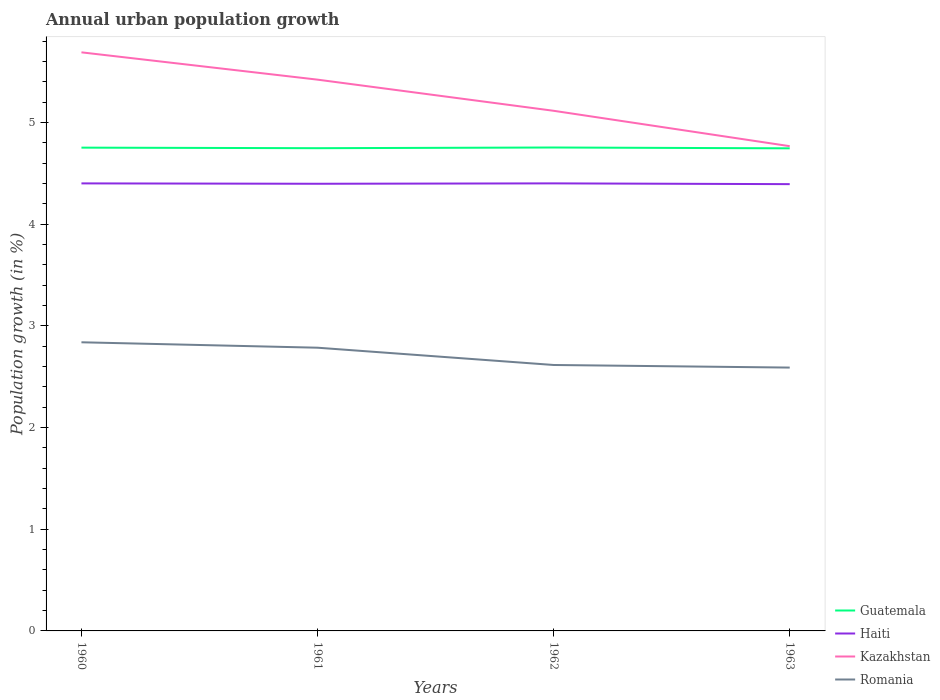How many different coloured lines are there?
Keep it short and to the point. 4. Is the number of lines equal to the number of legend labels?
Ensure brevity in your answer.  Yes. Across all years, what is the maximum percentage of urban population growth in Haiti?
Your answer should be compact. 4.39. What is the total percentage of urban population growth in Haiti in the graph?
Offer a terse response. -7.547159745957543e-5. What is the difference between the highest and the second highest percentage of urban population growth in Kazakhstan?
Offer a terse response. 0.92. Is the percentage of urban population growth in Romania strictly greater than the percentage of urban population growth in Haiti over the years?
Offer a terse response. Yes. How many lines are there?
Your answer should be compact. 4. How many years are there in the graph?
Offer a terse response. 4. What is the title of the graph?
Give a very brief answer. Annual urban population growth. Does "Argentina" appear as one of the legend labels in the graph?
Provide a short and direct response. No. What is the label or title of the X-axis?
Your answer should be very brief. Years. What is the label or title of the Y-axis?
Keep it short and to the point. Population growth (in %). What is the Population growth (in %) in Guatemala in 1960?
Offer a terse response. 4.75. What is the Population growth (in %) of Haiti in 1960?
Offer a very short reply. 4.4. What is the Population growth (in %) in Kazakhstan in 1960?
Keep it short and to the point. 5.69. What is the Population growth (in %) in Romania in 1960?
Offer a very short reply. 2.84. What is the Population growth (in %) of Guatemala in 1961?
Ensure brevity in your answer.  4.75. What is the Population growth (in %) of Haiti in 1961?
Ensure brevity in your answer.  4.4. What is the Population growth (in %) of Kazakhstan in 1961?
Provide a succinct answer. 5.42. What is the Population growth (in %) in Romania in 1961?
Your answer should be compact. 2.79. What is the Population growth (in %) in Guatemala in 1962?
Give a very brief answer. 4.75. What is the Population growth (in %) in Haiti in 1962?
Provide a succinct answer. 4.4. What is the Population growth (in %) in Kazakhstan in 1962?
Make the answer very short. 5.12. What is the Population growth (in %) of Romania in 1962?
Give a very brief answer. 2.62. What is the Population growth (in %) in Guatemala in 1963?
Give a very brief answer. 4.75. What is the Population growth (in %) of Haiti in 1963?
Make the answer very short. 4.39. What is the Population growth (in %) in Kazakhstan in 1963?
Offer a very short reply. 4.77. What is the Population growth (in %) of Romania in 1963?
Your response must be concise. 2.59. Across all years, what is the maximum Population growth (in %) of Guatemala?
Make the answer very short. 4.75. Across all years, what is the maximum Population growth (in %) in Haiti?
Give a very brief answer. 4.4. Across all years, what is the maximum Population growth (in %) of Kazakhstan?
Give a very brief answer. 5.69. Across all years, what is the maximum Population growth (in %) of Romania?
Offer a very short reply. 2.84. Across all years, what is the minimum Population growth (in %) of Guatemala?
Give a very brief answer. 4.75. Across all years, what is the minimum Population growth (in %) of Haiti?
Keep it short and to the point. 4.39. Across all years, what is the minimum Population growth (in %) of Kazakhstan?
Offer a very short reply. 4.77. Across all years, what is the minimum Population growth (in %) of Romania?
Provide a short and direct response. 2.59. What is the total Population growth (in %) of Guatemala in the graph?
Your answer should be very brief. 19. What is the total Population growth (in %) in Haiti in the graph?
Offer a very short reply. 17.59. What is the total Population growth (in %) of Kazakhstan in the graph?
Your answer should be very brief. 20.99. What is the total Population growth (in %) of Romania in the graph?
Give a very brief answer. 10.83. What is the difference between the Population growth (in %) in Guatemala in 1960 and that in 1961?
Offer a terse response. 0.01. What is the difference between the Population growth (in %) in Haiti in 1960 and that in 1961?
Offer a terse response. 0. What is the difference between the Population growth (in %) of Kazakhstan in 1960 and that in 1961?
Offer a very short reply. 0.27. What is the difference between the Population growth (in %) in Romania in 1960 and that in 1961?
Make the answer very short. 0.05. What is the difference between the Population growth (in %) of Guatemala in 1960 and that in 1962?
Offer a very short reply. -0. What is the difference between the Population growth (in %) in Haiti in 1960 and that in 1962?
Your answer should be compact. -0. What is the difference between the Population growth (in %) in Kazakhstan in 1960 and that in 1962?
Offer a terse response. 0.57. What is the difference between the Population growth (in %) in Romania in 1960 and that in 1962?
Keep it short and to the point. 0.22. What is the difference between the Population growth (in %) in Guatemala in 1960 and that in 1963?
Offer a very short reply. 0.01. What is the difference between the Population growth (in %) of Haiti in 1960 and that in 1963?
Your answer should be very brief. 0.01. What is the difference between the Population growth (in %) of Kazakhstan in 1960 and that in 1963?
Keep it short and to the point. 0.92. What is the difference between the Population growth (in %) of Romania in 1960 and that in 1963?
Keep it short and to the point. 0.25. What is the difference between the Population growth (in %) of Guatemala in 1961 and that in 1962?
Keep it short and to the point. -0.01. What is the difference between the Population growth (in %) in Haiti in 1961 and that in 1962?
Provide a succinct answer. -0. What is the difference between the Population growth (in %) in Kazakhstan in 1961 and that in 1962?
Offer a very short reply. 0.31. What is the difference between the Population growth (in %) in Romania in 1961 and that in 1962?
Provide a succinct answer. 0.17. What is the difference between the Population growth (in %) in Guatemala in 1961 and that in 1963?
Make the answer very short. 0. What is the difference between the Population growth (in %) in Haiti in 1961 and that in 1963?
Your answer should be compact. 0. What is the difference between the Population growth (in %) in Kazakhstan in 1961 and that in 1963?
Offer a very short reply. 0.65. What is the difference between the Population growth (in %) of Romania in 1961 and that in 1963?
Your response must be concise. 0.2. What is the difference between the Population growth (in %) in Guatemala in 1962 and that in 1963?
Provide a short and direct response. 0.01. What is the difference between the Population growth (in %) in Haiti in 1962 and that in 1963?
Your answer should be very brief. 0.01. What is the difference between the Population growth (in %) of Kazakhstan in 1962 and that in 1963?
Provide a succinct answer. 0.35. What is the difference between the Population growth (in %) of Romania in 1962 and that in 1963?
Give a very brief answer. 0.03. What is the difference between the Population growth (in %) in Guatemala in 1960 and the Population growth (in %) in Haiti in 1961?
Give a very brief answer. 0.36. What is the difference between the Population growth (in %) of Guatemala in 1960 and the Population growth (in %) of Kazakhstan in 1961?
Keep it short and to the point. -0.67. What is the difference between the Population growth (in %) in Guatemala in 1960 and the Population growth (in %) in Romania in 1961?
Keep it short and to the point. 1.97. What is the difference between the Population growth (in %) of Haiti in 1960 and the Population growth (in %) of Kazakhstan in 1961?
Make the answer very short. -1.02. What is the difference between the Population growth (in %) in Haiti in 1960 and the Population growth (in %) in Romania in 1961?
Your answer should be compact. 1.62. What is the difference between the Population growth (in %) in Kazakhstan in 1960 and the Population growth (in %) in Romania in 1961?
Make the answer very short. 2.9. What is the difference between the Population growth (in %) in Guatemala in 1960 and the Population growth (in %) in Haiti in 1962?
Ensure brevity in your answer.  0.35. What is the difference between the Population growth (in %) in Guatemala in 1960 and the Population growth (in %) in Kazakhstan in 1962?
Make the answer very short. -0.36. What is the difference between the Population growth (in %) in Guatemala in 1960 and the Population growth (in %) in Romania in 1962?
Provide a short and direct response. 2.14. What is the difference between the Population growth (in %) in Haiti in 1960 and the Population growth (in %) in Kazakhstan in 1962?
Provide a succinct answer. -0.71. What is the difference between the Population growth (in %) of Haiti in 1960 and the Population growth (in %) of Romania in 1962?
Make the answer very short. 1.79. What is the difference between the Population growth (in %) of Kazakhstan in 1960 and the Population growth (in %) of Romania in 1962?
Your response must be concise. 3.07. What is the difference between the Population growth (in %) of Guatemala in 1960 and the Population growth (in %) of Haiti in 1963?
Make the answer very short. 0.36. What is the difference between the Population growth (in %) in Guatemala in 1960 and the Population growth (in %) in Kazakhstan in 1963?
Provide a succinct answer. -0.01. What is the difference between the Population growth (in %) of Guatemala in 1960 and the Population growth (in %) of Romania in 1963?
Give a very brief answer. 2.16. What is the difference between the Population growth (in %) in Haiti in 1960 and the Population growth (in %) in Kazakhstan in 1963?
Provide a short and direct response. -0.37. What is the difference between the Population growth (in %) of Haiti in 1960 and the Population growth (in %) of Romania in 1963?
Offer a very short reply. 1.81. What is the difference between the Population growth (in %) of Kazakhstan in 1960 and the Population growth (in %) of Romania in 1963?
Provide a succinct answer. 3.1. What is the difference between the Population growth (in %) in Guatemala in 1961 and the Population growth (in %) in Haiti in 1962?
Your answer should be compact. 0.35. What is the difference between the Population growth (in %) in Guatemala in 1961 and the Population growth (in %) in Kazakhstan in 1962?
Keep it short and to the point. -0.37. What is the difference between the Population growth (in %) of Guatemala in 1961 and the Population growth (in %) of Romania in 1962?
Offer a terse response. 2.13. What is the difference between the Population growth (in %) of Haiti in 1961 and the Population growth (in %) of Kazakhstan in 1962?
Your answer should be very brief. -0.72. What is the difference between the Population growth (in %) in Haiti in 1961 and the Population growth (in %) in Romania in 1962?
Keep it short and to the point. 1.78. What is the difference between the Population growth (in %) in Kazakhstan in 1961 and the Population growth (in %) in Romania in 1962?
Ensure brevity in your answer.  2.81. What is the difference between the Population growth (in %) in Guatemala in 1961 and the Population growth (in %) in Haiti in 1963?
Your response must be concise. 0.35. What is the difference between the Population growth (in %) in Guatemala in 1961 and the Population growth (in %) in Kazakhstan in 1963?
Give a very brief answer. -0.02. What is the difference between the Population growth (in %) of Guatemala in 1961 and the Population growth (in %) of Romania in 1963?
Your answer should be very brief. 2.16. What is the difference between the Population growth (in %) in Haiti in 1961 and the Population growth (in %) in Kazakhstan in 1963?
Keep it short and to the point. -0.37. What is the difference between the Population growth (in %) in Haiti in 1961 and the Population growth (in %) in Romania in 1963?
Give a very brief answer. 1.81. What is the difference between the Population growth (in %) of Kazakhstan in 1961 and the Population growth (in %) of Romania in 1963?
Keep it short and to the point. 2.83. What is the difference between the Population growth (in %) in Guatemala in 1962 and the Population growth (in %) in Haiti in 1963?
Ensure brevity in your answer.  0.36. What is the difference between the Population growth (in %) of Guatemala in 1962 and the Population growth (in %) of Kazakhstan in 1963?
Make the answer very short. -0.01. What is the difference between the Population growth (in %) in Guatemala in 1962 and the Population growth (in %) in Romania in 1963?
Your answer should be very brief. 2.16. What is the difference between the Population growth (in %) in Haiti in 1962 and the Population growth (in %) in Kazakhstan in 1963?
Give a very brief answer. -0.37. What is the difference between the Population growth (in %) in Haiti in 1962 and the Population growth (in %) in Romania in 1963?
Offer a very short reply. 1.81. What is the difference between the Population growth (in %) of Kazakhstan in 1962 and the Population growth (in %) of Romania in 1963?
Provide a succinct answer. 2.53. What is the average Population growth (in %) of Guatemala per year?
Give a very brief answer. 4.75. What is the average Population growth (in %) of Haiti per year?
Your response must be concise. 4.4. What is the average Population growth (in %) of Kazakhstan per year?
Provide a short and direct response. 5.25. What is the average Population growth (in %) in Romania per year?
Ensure brevity in your answer.  2.71. In the year 1960, what is the difference between the Population growth (in %) of Guatemala and Population growth (in %) of Haiti?
Your answer should be compact. 0.35. In the year 1960, what is the difference between the Population growth (in %) in Guatemala and Population growth (in %) in Kazakhstan?
Provide a short and direct response. -0.94. In the year 1960, what is the difference between the Population growth (in %) in Guatemala and Population growth (in %) in Romania?
Your answer should be compact. 1.91. In the year 1960, what is the difference between the Population growth (in %) in Haiti and Population growth (in %) in Kazakhstan?
Provide a short and direct response. -1.29. In the year 1960, what is the difference between the Population growth (in %) in Haiti and Population growth (in %) in Romania?
Provide a succinct answer. 1.56. In the year 1960, what is the difference between the Population growth (in %) in Kazakhstan and Population growth (in %) in Romania?
Keep it short and to the point. 2.85. In the year 1961, what is the difference between the Population growth (in %) of Guatemala and Population growth (in %) of Kazakhstan?
Make the answer very short. -0.67. In the year 1961, what is the difference between the Population growth (in %) in Guatemala and Population growth (in %) in Romania?
Your answer should be compact. 1.96. In the year 1961, what is the difference between the Population growth (in %) in Haiti and Population growth (in %) in Kazakhstan?
Offer a very short reply. -1.02. In the year 1961, what is the difference between the Population growth (in %) in Haiti and Population growth (in %) in Romania?
Your answer should be very brief. 1.61. In the year 1961, what is the difference between the Population growth (in %) of Kazakhstan and Population growth (in %) of Romania?
Make the answer very short. 2.64. In the year 1962, what is the difference between the Population growth (in %) in Guatemala and Population growth (in %) in Haiti?
Give a very brief answer. 0.35. In the year 1962, what is the difference between the Population growth (in %) in Guatemala and Population growth (in %) in Kazakhstan?
Keep it short and to the point. -0.36. In the year 1962, what is the difference between the Population growth (in %) in Guatemala and Population growth (in %) in Romania?
Provide a short and direct response. 2.14. In the year 1962, what is the difference between the Population growth (in %) of Haiti and Population growth (in %) of Kazakhstan?
Your answer should be compact. -0.71. In the year 1962, what is the difference between the Population growth (in %) in Haiti and Population growth (in %) in Romania?
Your response must be concise. 1.79. In the year 1963, what is the difference between the Population growth (in %) of Guatemala and Population growth (in %) of Haiti?
Offer a terse response. 0.35. In the year 1963, what is the difference between the Population growth (in %) of Guatemala and Population growth (in %) of Kazakhstan?
Your response must be concise. -0.02. In the year 1963, what is the difference between the Population growth (in %) in Guatemala and Population growth (in %) in Romania?
Offer a terse response. 2.16. In the year 1963, what is the difference between the Population growth (in %) of Haiti and Population growth (in %) of Kazakhstan?
Offer a very short reply. -0.37. In the year 1963, what is the difference between the Population growth (in %) in Haiti and Population growth (in %) in Romania?
Your answer should be compact. 1.8. In the year 1963, what is the difference between the Population growth (in %) in Kazakhstan and Population growth (in %) in Romania?
Give a very brief answer. 2.18. What is the ratio of the Population growth (in %) in Guatemala in 1960 to that in 1961?
Keep it short and to the point. 1. What is the ratio of the Population growth (in %) in Haiti in 1960 to that in 1961?
Make the answer very short. 1. What is the ratio of the Population growth (in %) of Kazakhstan in 1960 to that in 1961?
Offer a terse response. 1.05. What is the ratio of the Population growth (in %) in Romania in 1960 to that in 1961?
Give a very brief answer. 1.02. What is the ratio of the Population growth (in %) of Haiti in 1960 to that in 1962?
Your response must be concise. 1. What is the ratio of the Population growth (in %) in Kazakhstan in 1960 to that in 1962?
Your answer should be compact. 1.11. What is the ratio of the Population growth (in %) in Romania in 1960 to that in 1962?
Provide a succinct answer. 1.09. What is the ratio of the Population growth (in %) of Kazakhstan in 1960 to that in 1963?
Your answer should be very brief. 1.19. What is the ratio of the Population growth (in %) in Romania in 1960 to that in 1963?
Offer a very short reply. 1.1. What is the ratio of the Population growth (in %) in Guatemala in 1961 to that in 1962?
Ensure brevity in your answer.  1. What is the ratio of the Population growth (in %) of Haiti in 1961 to that in 1962?
Your answer should be very brief. 1. What is the ratio of the Population growth (in %) of Kazakhstan in 1961 to that in 1962?
Keep it short and to the point. 1.06. What is the ratio of the Population growth (in %) of Romania in 1961 to that in 1962?
Your response must be concise. 1.06. What is the ratio of the Population growth (in %) in Haiti in 1961 to that in 1963?
Give a very brief answer. 1. What is the ratio of the Population growth (in %) in Kazakhstan in 1961 to that in 1963?
Provide a succinct answer. 1.14. What is the ratio of the Population growth (in %) in Romania in 1961 to that in 1963?
Make the answer very short. 1.08. What is the ratio of the Population growth (in %) in Guatemala in 1962 to that in 1963?
Your answer should be very brief. 1. What is the ratio of the Population growth (in %) of Kazakhstan in 1962 to that in 1963?
Provide a short and direct response. 1.07. What is the ratio of the Population growth (in %) in Romania in 1962 to that in 1963?
Provide a succinct answer. 1.01. What is the difference between the highest and the second highest Population growth (in %) in Guatemala?
Offer a terse response. 0. What is the difference between the highest and the second highest Population growth (in %) in Kazakhstan?
Ensure brevity in your answer.  0.27. What is the difference between the highest and the second highest Population growth (in %) of Romania?
Offer a terse response. 0.05. What is the difference between the highest and the lowest Population growth (in %) in Guatemala?
Make the answer very short. 0.01. What is the difference between the highest and the lowest Population growth (in %) in Haiti?
Offer a terse response. 0.01. What is the difference between the highest and the lowest Population growth (in %) in Kazakhstan?
Keep it short and to the point. 0.92. What is the difference between the highest and the lowest Population growth (in %) of Romania?
Your response must be concise. 0.25. 